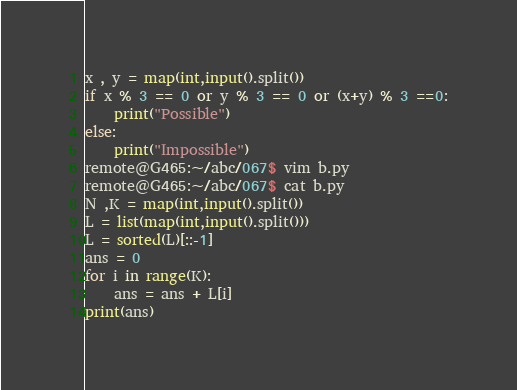<code> <loc_0><loc_0><loc_500><loc_500><_Python_>x , y = map(int,input().split())
if x % 3 == 0 or y % 3 == 0 or (x+y) % 3 ==0:
    print("Possible")
else:
    print("Impossible")
remote@G465:~/abc/067$ vim b.py
remote@G465:~/abc/067$ cat b.py
N ,K = map(int,input().split())
L = list(map(int,input().split()))
L = sorted(L)[::-1]
ans = 0
for i in range(K):
    ans = ans + L[i]
print(ans)
</code> 